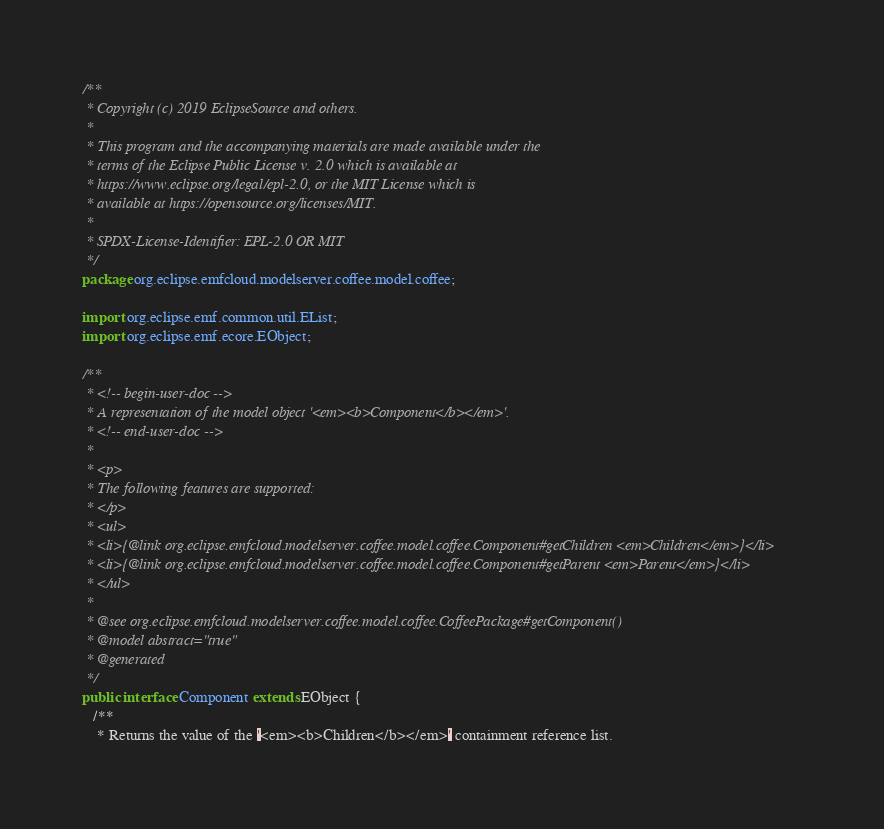Convert code to text. <code><loc_0><loc_0><loc_500><loc_500><_Java_>/**
 * Copyright (c) 2019 EclipseSource and others.
 *
 * This program and the accompanying materials are made available under the
 * terms of the Eclipse Public License v. 2.0 which is available at
 * https://www.eclipse.org/legal/epl-2.0, or the MIT License which is
 * available at https://opensource.org/licenses/MIT.
 *
 * SPDX-License-Identifier: EPL-2.0 OR MIT
 */
package org.eclipse.emfcloud.modelserver.coffee.model.coffee;

import org.eclipse.emf.common.util.EList;
import org.eclipse.emf.ecore.EObject;

/**
 * <!-- begin-user-doc -->
 * A representation of the model object '<em><b>Component</b></em>'.
 * <!-- end-user-doc -->
 *
 * <p>
 * The following features are supported:
 * </p>
 * <ul>
 * <li>{@link org.eclipse.emfcloud.modelserver.coffee.model.coffee.Component#getChildren <em>Children</em>}</li>
 * <li>{@link org.eclipse.emfcloud.modelserver.coffee.model.coffee.Component#getParent <em>Parent</em>}</li>
 * </ul>
 *
 * @see org.eclipse.emfcloud.modelserver.coffee.model.coffee.CoffeePackage#getComponent()
 * @model abstract="true"
 * @generated
 */
public interface Component extends EObject {
   /**
    * Returns the value of the '<em><b>Children</b></em>' containment reference list.</code> 